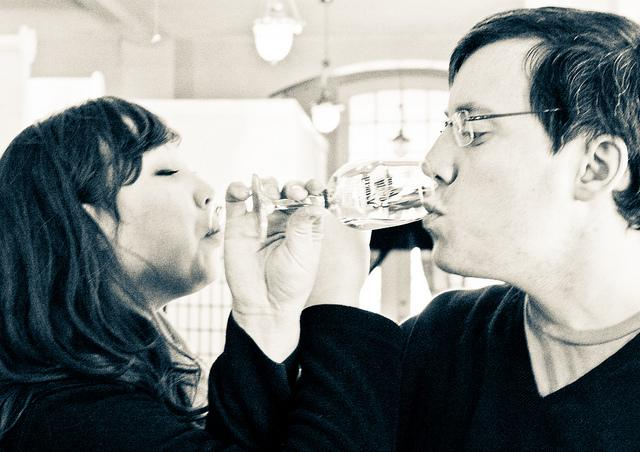What kind of beverage are the couple most likely drinking together? Please explain your reasoning. water. The glasses the couple are drinking from are commonly used for drinking this beverage as it enhances the taste. 